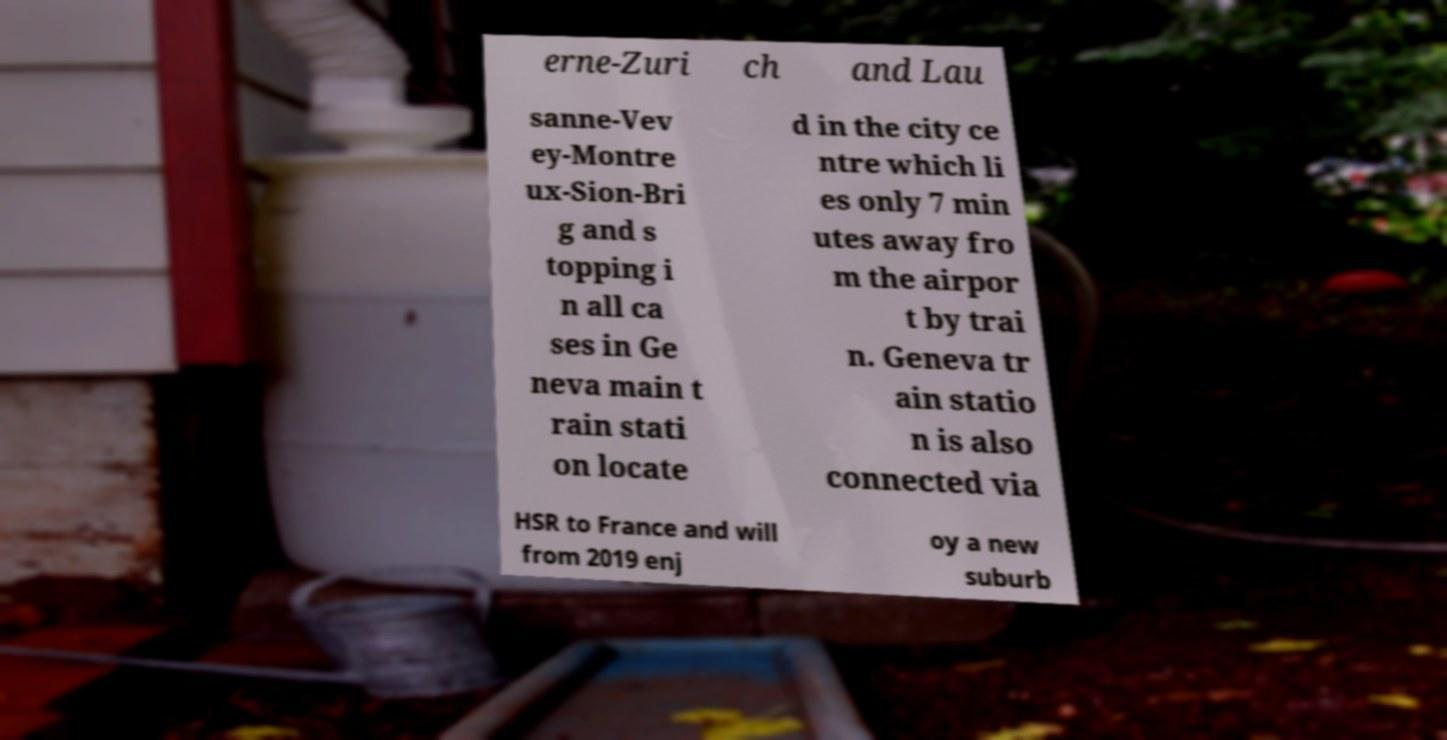Please identify and transcribe the text found in this image. erne-Zuri ch and Lau sanne-Vev ey-Montre ux-Sion-Bri g and s topping i n all ca ses in Ge neva main t rain stati on locate d in the city ce ntre which li es only 7 min utes away fro m the airpor t by trai n. Geneva tr ain statio n is also connected via HSR to France and will from 2019 enj oy a new suburb 